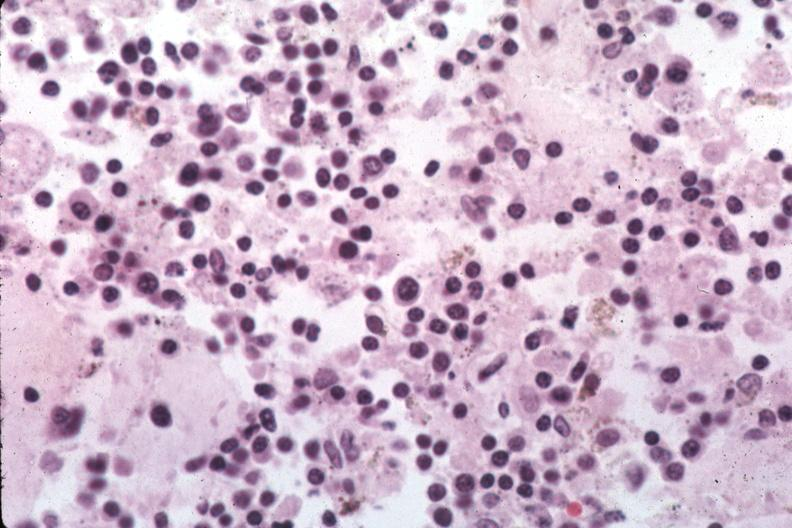what is present?
Answer the question using a single word or phrase. Bone marrow 